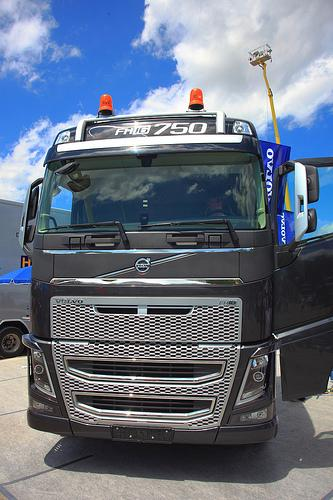Mention the different colors and objects you can see in the sky. I can see blue sky, white clouds, and a yellow crane in the distance. Identify the color and type of the umbrella in the image. The umbrella in the image is blue and it appears to be a patio or beach umbrella. What kind of construction equipment can be seen in the distance and what is its color? In the distance, there is a yellow crane with a bucket on it. Describe the weather conditions and the sky in the image. The weather seems clear with a blue sky, white clouds, and no signs of any storm or rain. In what state is the door of the driver in the truck and where can you find the rear view mirror? The driver's door on the truck is open and the rearview mirror is located on the window. What is the condition depicted in the sky and list the different clouds mentioned in the image. The sky is clear with white clouds: there are three sets of white clouds mentioned in the imagees. Count the number of objects mentioned in the image that are related to the truck. There are 8 objects related to the truck: grille, rearview mirror, open driver's door, black wheels, front part, numbers on top, windshield with wipers, and headlights. What type of vehicle is the main subject in this image and what are its characteristics? The main subject is a black truck, or lorry, with black wheels, an open driver's door, rearview mirror, windshield wipers, headlights, and numbers on top. 